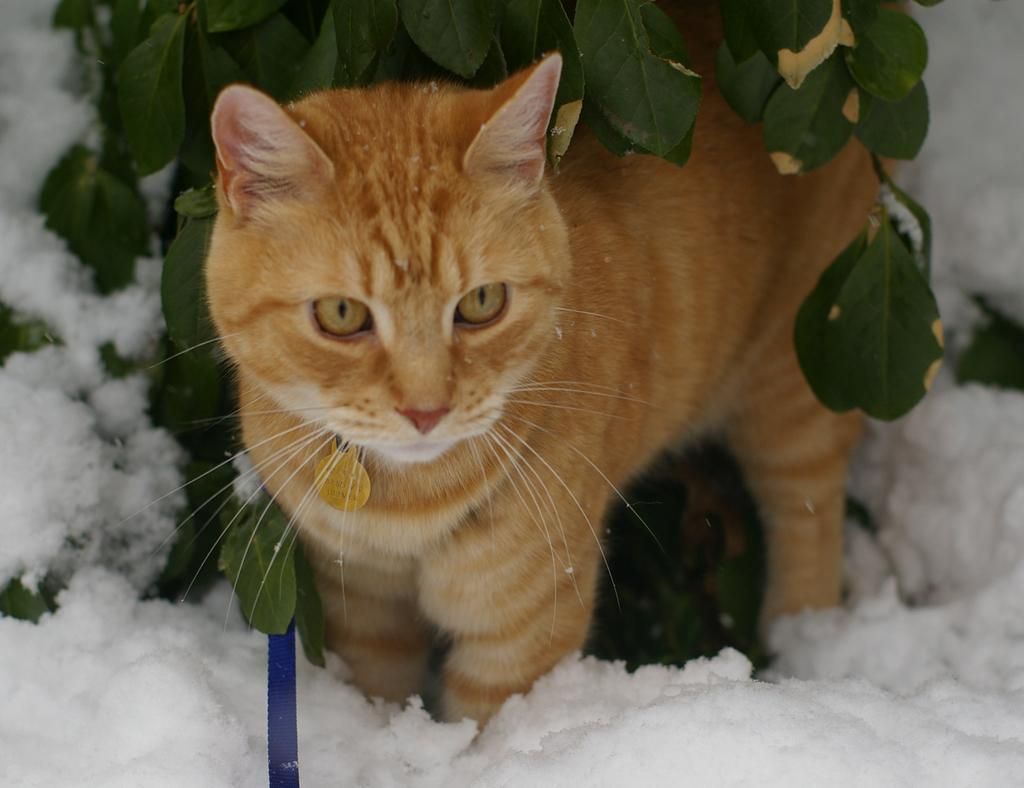What is the condition of the ground in the image? There is snow on the ground in the image. What animal can be seen in the snow? There is a brown color cat standing in the snow. What is above the cat in the image? There are leaves above the cat. What type of credit card is the cat holding in the image? There is no credit card present in the image; it features a brown cat standing in the snow with leaves above it. Can you tell me how many cows are visible in the image? There are no cows present in the image. 